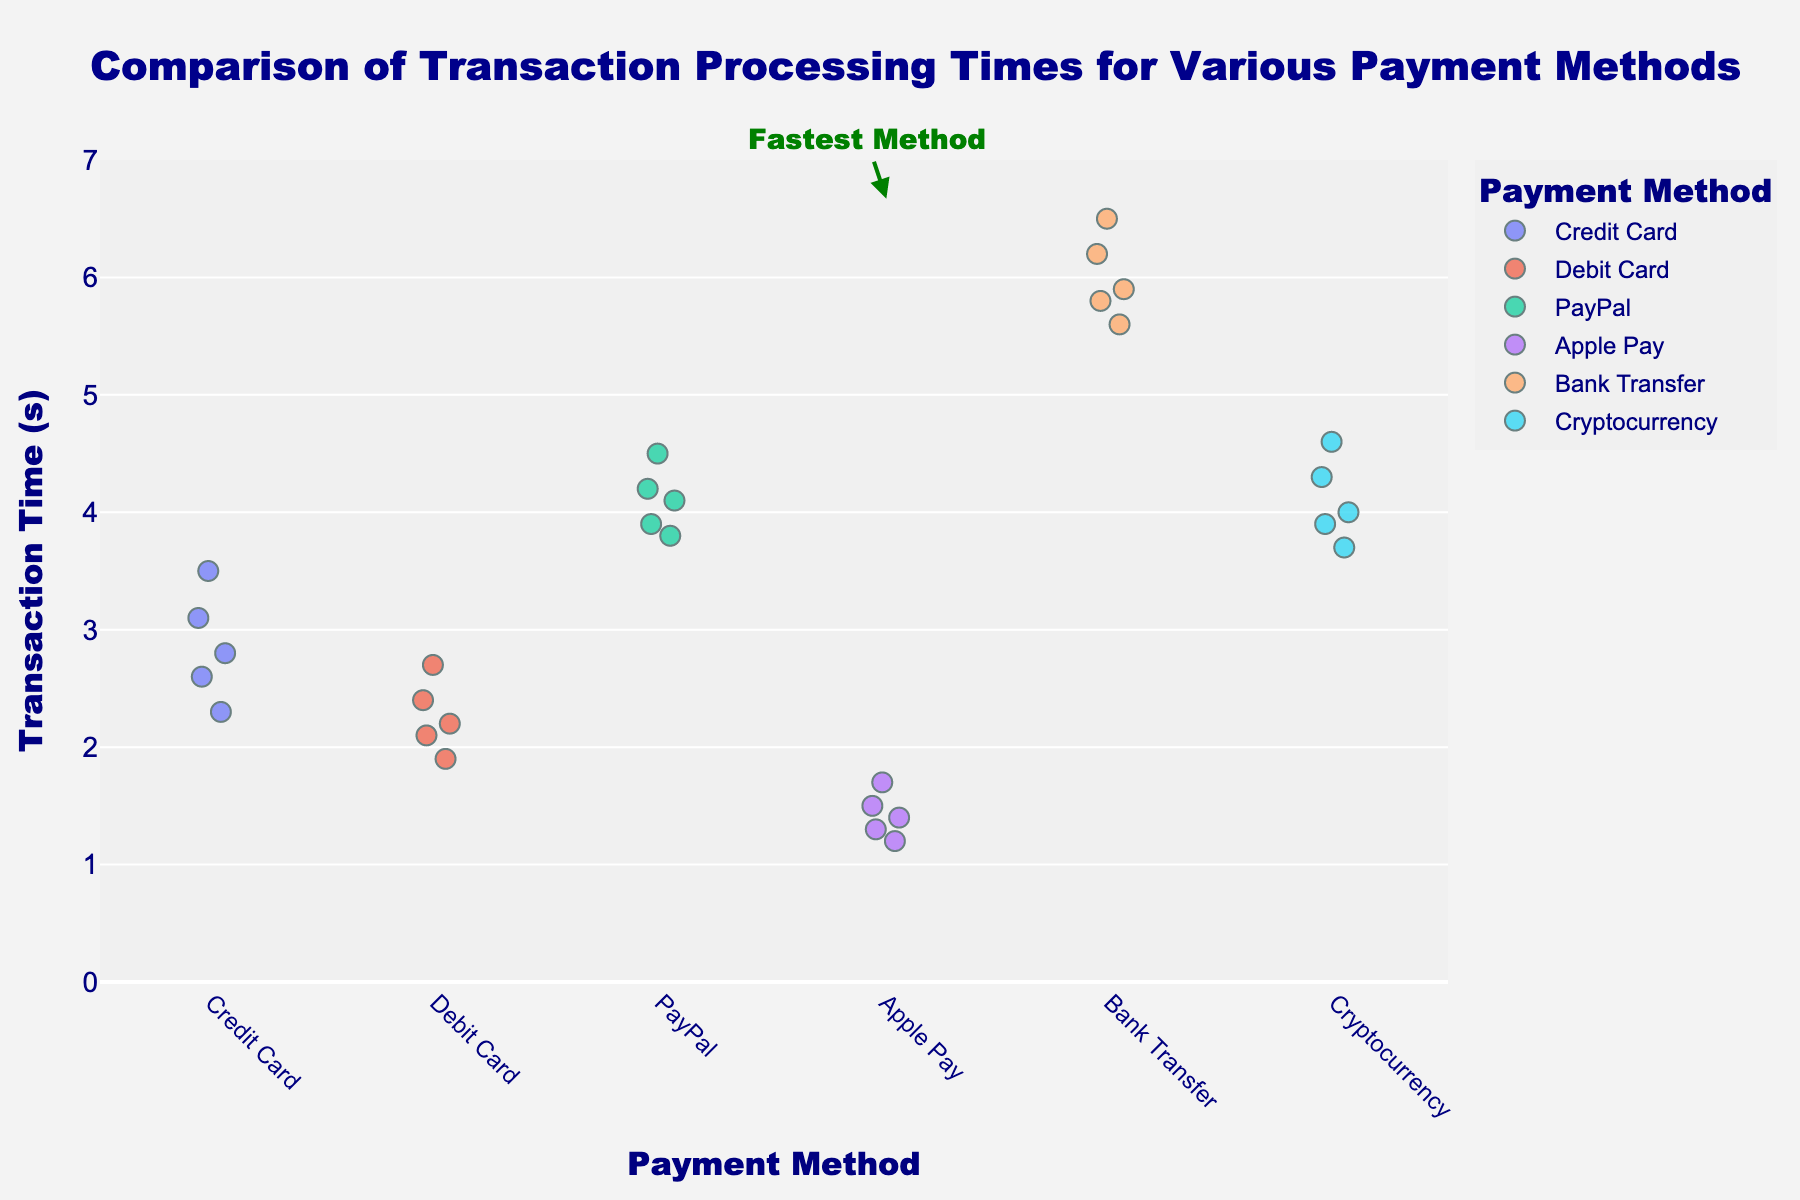How many different payment methods are displayed in the chart? Count the number of distinct labels on the x-axis. There are six labels, one for each payment method: Credit Card, Debit Card, PayPal, Apple Pay, Bank Transfer, and Cryptocurrency.
Answer: Six Which payment method has the fastest average transaction time? The plot highlights the fastest method with a light green rectangle and an annotation "Fastest Method" pointing to Apple Pay.
Answer: Apple Pay What is the range of transaction times for the Credit Card payment method? Look at the spread of data points for Credit Card on the y-axis. The lowest point is at 2.3 seconds and the highest is at 3.5 seconds. The range is 3.5 - 2.3 = 1.2.
Answer: 1.2 seconds Which payment method shows the highest variability in transaction times? Assess the vertical spread of data points for each payment method. Bank Transfer spans a wide range from 5.6 to 6.5 seconds, indicating the highest variability.
Answer: Bank Transfer Are there any payment methods with transaction times less than 2 seconds? Check the y-axis values for each payment method. Apple Pay has transaction times below 2 seconds, with points at 1.2, 1.3, 1.4, 1.5, and 1.7 seconds.
Answer: Apple Pay What is the median transaction time for the Debit Card payment method? Order the transaction times for Debit Card: 1.9, 2.1, 2.2, 2.4, 2.7. The median value is the middle data point, which is 2.2 seconds.
Answer: 2.2 seconds Which payment method has the longest transaction time, and what is this time? Look for the highest point on the y-axis among all methods. Bank Transfer has the longest time at 6.5 seconds.
Answer: Bank Transfer, 6.5 seconds Do any payment methods have overlapping transaction time ranges? Compare the y-axis ranges of different payment methods. Credit Card (2.3-3.5s) and Debit Card (1.9-2.7s) overlap in the range of 2.3 to 2.7 seconds.
Answer: Yes, Credit Card and Debit Card How much faster is the fastest transaction time compared to the slowest? Identify the minimum transaction time (1.2 seconds for Apple Pay) and the maximum transaction time (6.5 seconds for Bank Transfer). The difference is 6.5 - 1.2 = 5.3 seconds.
Answer: 5.3 seconds 